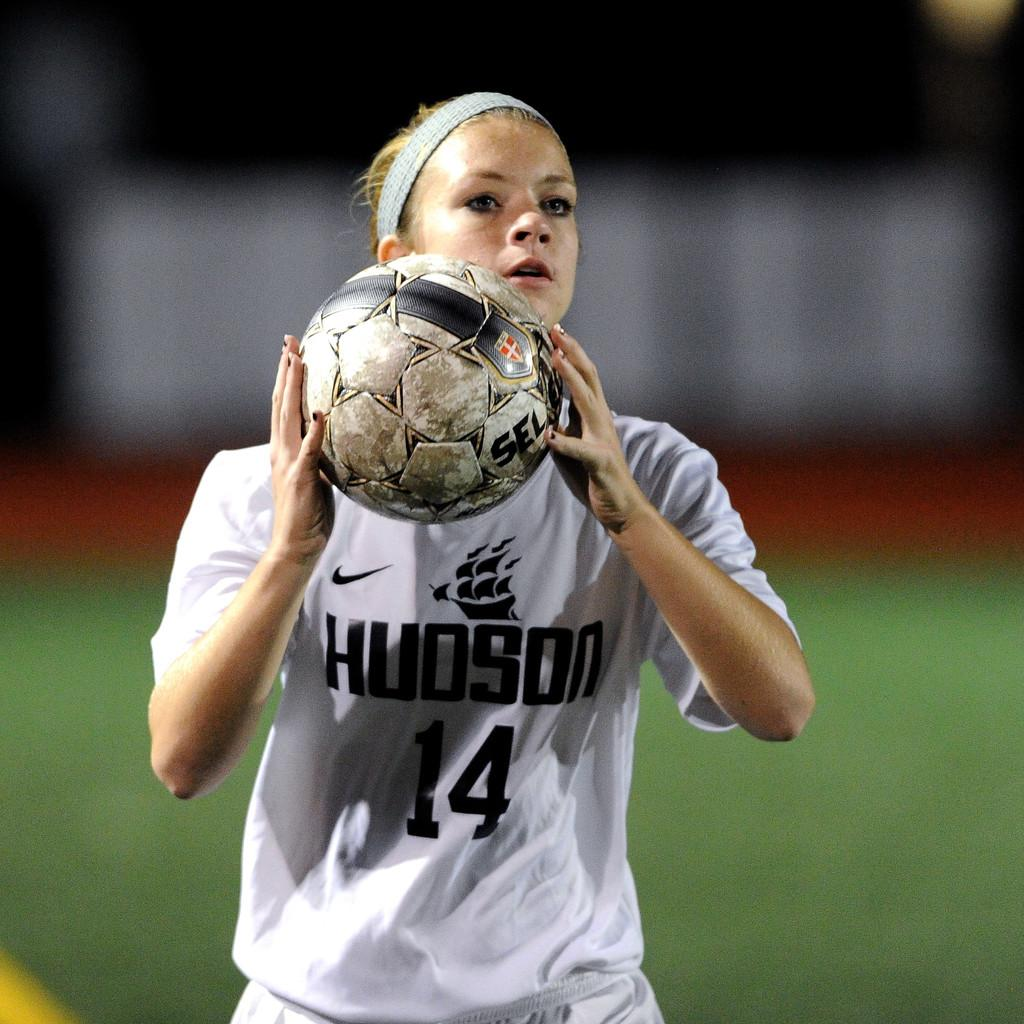<image>
Give a short and clear explanation of the subsequent image. a woman in a Hudson 14 jersey about to throw a ball 